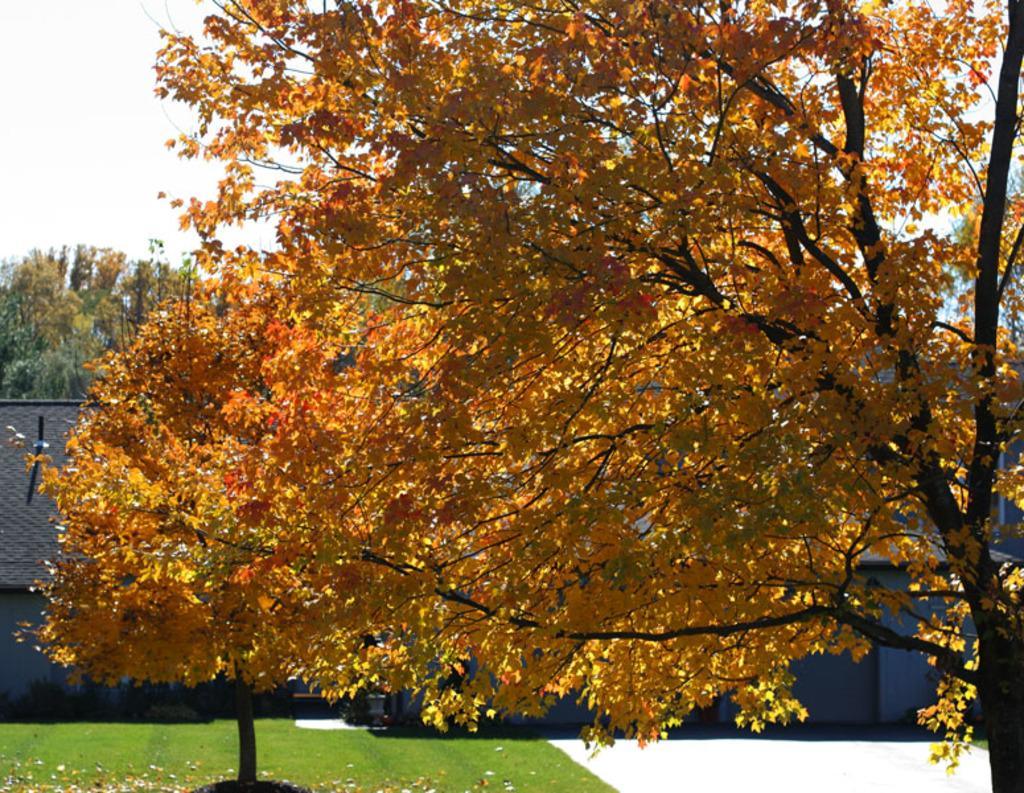What type of vegetation can be seen in the image? There is grass in the image. What type of structure is present in the image? There is a house in the image. What other natural elements can be seen in the image? There are trees in the image, including a tree with yellow leaves. What is visible in the background of the image? The sky is visible in the background of the image. Where is the vase located in the image? There is no vase present in the image. What season is depicted in the image, considering the yellow leaves on the tree? The image does not specify a season, as the presence of yellow leaves on a tree can occur in both autumn and spring, depending on the tree species. 